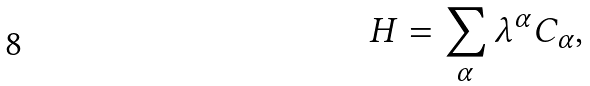Convert formula to latex. <formula><loc_0><loc_0><loc_500><loc_500>H = \sum _ { \alpha } \lambda ^ { \alpha } C _ { \alpha } ,</formula> 